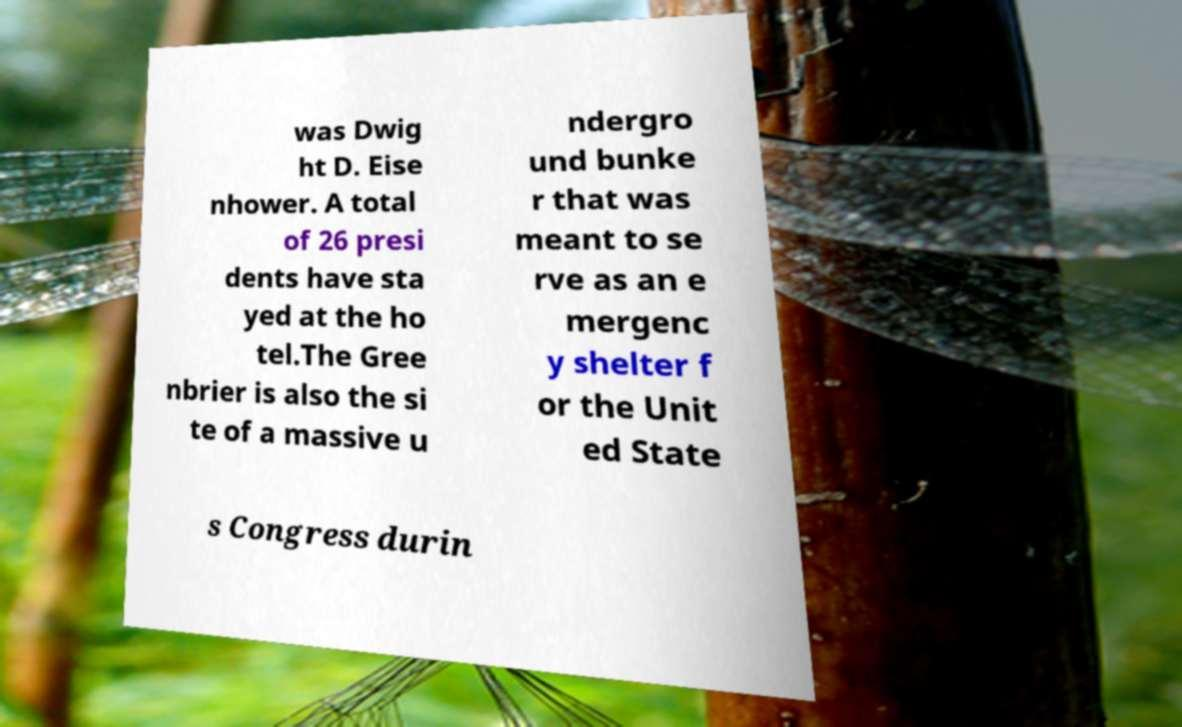Can you read and provide the text displayed in the image?This photo seems to have some interesting text. Can you extract and type it out for me? was Dwig ht D. Eise nhower. A total of 26 presi dents have sta yed at the ho tel.The Gree nbrier is also the si te of a massive u ndergro und bunke r that was meant to se rve as an e mergenc y shelter f or the Unit ed State s Congress durin 